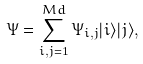Convert formula to latex. <formula><loc_0><loc_0><loc_500><loc_500>\Psi = \sum _ { i , j = 1 } ^ { M d } \Psi _ { i , j } | i \rangle | j \rangle ,</formula> 